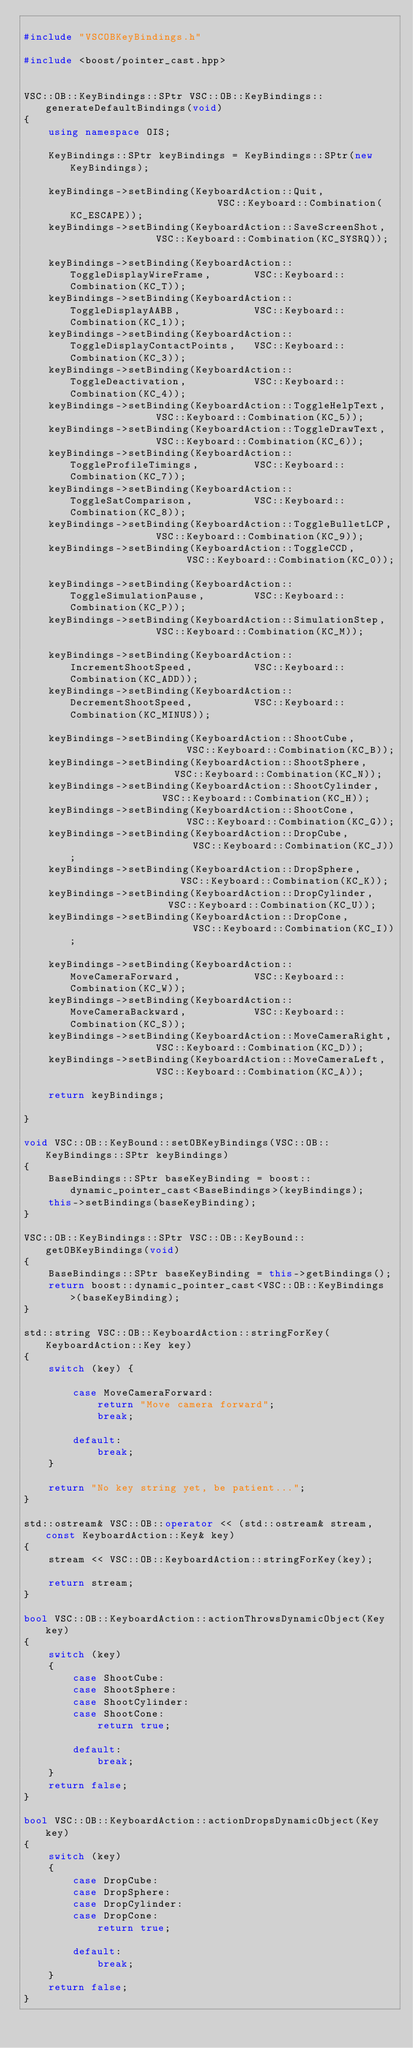<code> <loc_0><loc_0><loc_500><loc_500><_C++_>
#include "VSCOBKeyBindings.h"

#include <boost/pointer_cast.hpp>


VSC::OB::KeyBindings::SPtr VSC::OB::KeyBindings::generateDefaultBindings(void)
{
    using namespace OIS;
    
    KeyBindings::SPtr keyBindings = KeyBindings::SPtr(new KeyBindings);
    
    keyBindings->setBinding(KeyboardAction::Quit,                         VSC::Keyboard::Combination(KC_ESCAPE));
    keyBindings->setBinding(KeyboardAction::SaveScreenShot,               VSC::Keyboard::Combination(KC_SYSRQ));
    
    keyBindings->setBinding(KeyboardAction::ToggleDisplayWireFrame,       VSC::Keyboard::Combination(KC_T));
    keyBindings->setBinding(KeyboardAction::ToggleDisplayAABB,            VSC::Keyboard::Combination(KC_1));
    keyBindings->setBinding(KeyboardAction::ToggleDisplayContactPoints,   VSC::Keyboard::Combination(KC_3));
    keyBindings->setBinding(KeyboardAction::ToggleDeactivation,           VSC::Keyboard::Combination(KC_4));
    keyBindings->setBinding(KeyboardAction::ToggleHelpText,               VSC::Keyboard::Combination(KC_5));
    keyBindings->setBinding(KeyboardAction::ToggleDrawText,               VSC::Keyboard::Combination(KC_6));
    keyBindings->setBinding(KeyboardAction::ToggleProfileTimings,         VSC::Keyboard::Combination(KC_7));
    keyBindings->setBinding(KeyboardAction::ToggleSatComparison,          VSC::Keyboard::Combination(KC_8));
    keyBindings->setBinding(KeyboardAction::ToggleBulletLCP,              VSC::Keyboard::Combination(KC_9));
    keyBindings->setBinding(KeyboardAction::ToggleCCD,                    VSC::Keyboard::Combination(KC_0));
    
    keyBindings->setBinding(KeyboardAction::ToggleSimulationPause,        VSC::Keyboard::Combination(KC_P));
    keyBindings->setBinding(KeyboardAction::SimulationStep,               VSC::Keyboard::Combination(KC_M));
    
    keyBindings->setBinding(KeyboardAction::IncrementShootSpeed,          VSC::Keyboard::Combination(KC_ADD));
    keyBindings->setBinding(KeyboardAction::DecrementShootSpeed,          VSC::Keyboard::Combination(KC_MINUS));
    
    keyBindings->setBinding(KeyboardAction::ShootCube,                    VSC::Keyboard::Combination(KC_B));
    keyBindings->setBinding(KeyboardAction::ShootSphere,                  VSC::Keyboard::Combination(KC_N));
    keyBindings->setBinding(KeyboardAction::ShootCylinder,                VSC::Keyboard::Combination(KC_H));
    keyBindings->setBinding(KeyboardAction::ShootCone,                    VSC::Keyboard::Combination(KC_G));
    keyBindings->setBinding(KeyboardAction::DropCube,                     VSC::Keyboard::Combination(KC_J));
    keyBindings->setBinding(KeyboardAction::DropSphere,                   VSC::Keyboard::Combination(KC_K));
    keyBindings->setBinding(KeyboardAction::DropCylinder,                 VSC::Keyboard::Combination(KC_U));
    keyBindings->setBinding(KeyboardAction::DropCone,                     VSC::Keyboard::Combination(KC_I));
    
    keyBindings->setBinding(KeyboardAction::MoveCameraForward,            VSC::Keyboard::Combination(KC_W));
    keyBindings->setBinding(KeyboardAction::MoveCameraBackward,           VSC::Keyboard::Combination(KC_S));
    keyBindings->setBinding(KeyboardAction::MoveCameraRight,              VSC::Keyboard::Combination(KC_D));
    keyBindings->setBinding(KeyboardAction::MoveCameraLeft,               VSC::Keyboard::Combination(KC_A));
    
    return keyBindings;
    
}

void VSC::OB::KeyBound::setOBKeyBindings(VSC::OB::KeyBindings::SPtr keyBindings)
{
    BaseBindings::SPtr baseKeyBinding = boost::dynamic_pointer_cast<BaseBindings>(keyBindings);
    this->setBindings(baseKeyBinding);
}

VSC::OB::KeyBindings::SPtr VSC::OB::KeyBound::getOBKeyBindings(void)
{
    BaseBindings::SPtr baseKeyBinding = this->getBindings();
    return boost::dynamic_pointer_cast<VSC::OB::KeyBindings>(baseKeyBinding);
}

std::string VSC::OB::KeyboardAction::stringForKey(KeyboardAction::Key key)
{
    switch (key) {
            
        case MoveCameraForward:
            return "Move camera forward";
            break;
            
        default:
            break;
    }
    
    return "No key string yet, be patient...";
}

std::ostream& VSC::OB::operator << (std::ostream& stream, const KeyboardAction::Key& key)
{
    stream << VSC::OB::KeyboardAction::stringForKey(key);
    
    return stream;
}

bool VSC::OB::KeyboardAction::actionThrowsDynamicObject(Key key)
{
    switch (key)
    {
        case ShootCube:
        case ShootSphere:
        case ShootCylinder:
        case ShootCone:
            return true;
            
        default:
            break;
    }
    return false;
}

bool VSC::OB::KeyboardAction::actionDropsDynamicObject(Key key)
{
    switch (key)
    {
        case DropCube:
        case DropSphere:
        case DropCylinder:
        case DropCone:
            return true;
            
        default:
            break;
    }
    return false;
}

</code> 